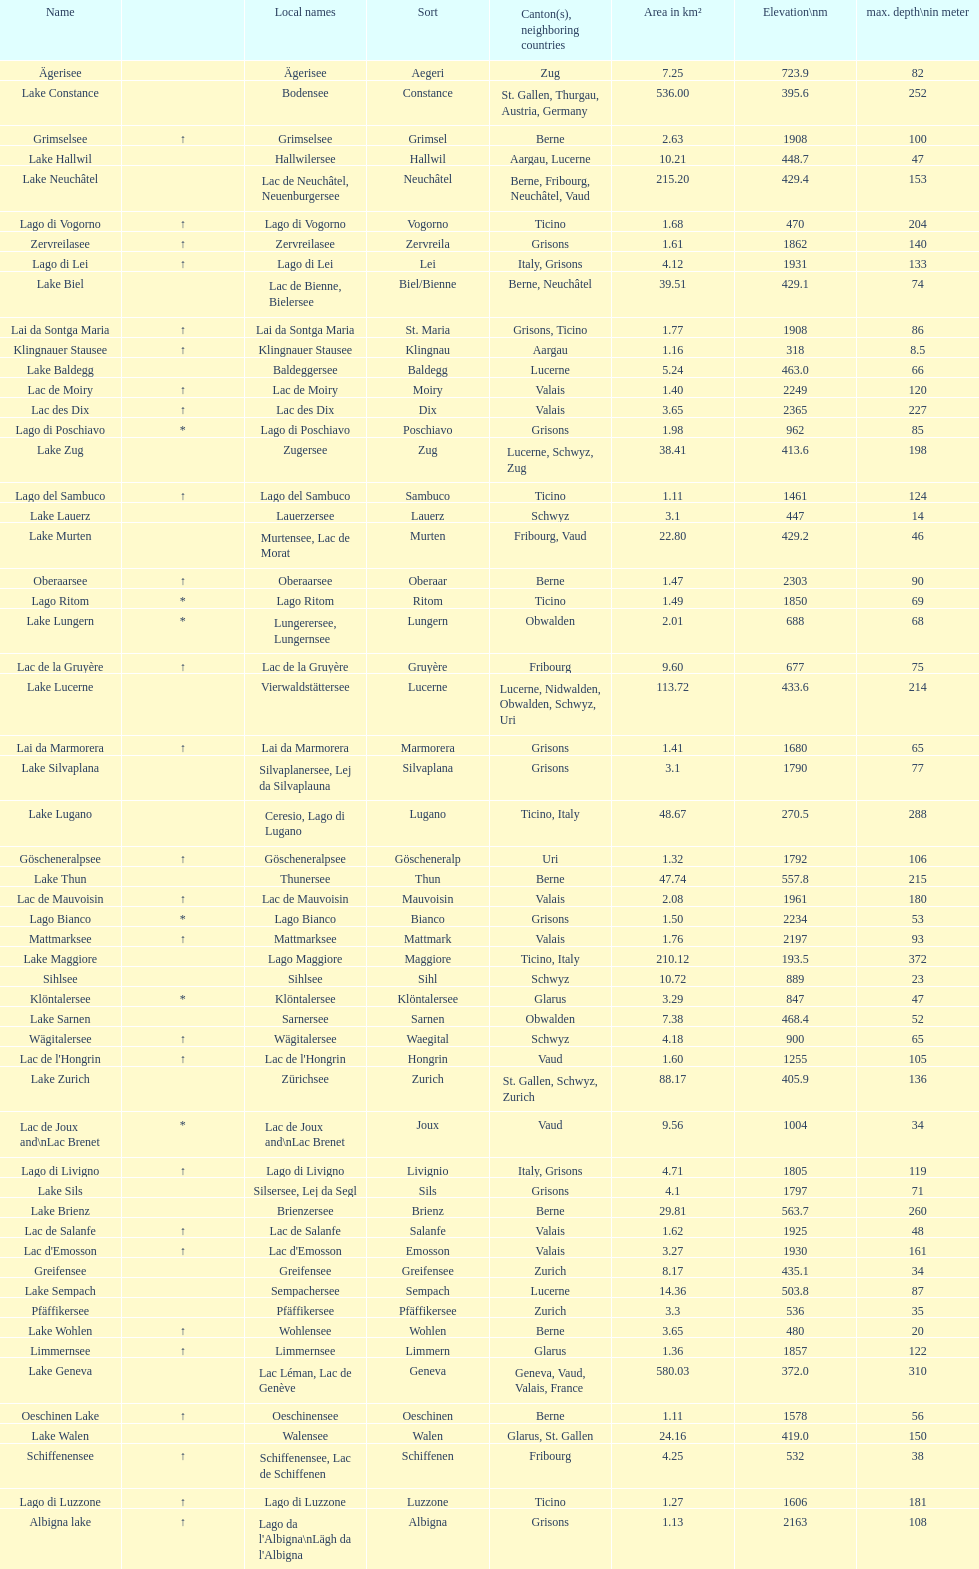What's the total max depth of lake geneva and lake constance combined? 562. Help me parse the entirety of this table. {'header': ['Name', '', 'Local names', 'Sort', 'Canton(s), neighboring countries', 'Area in km²', 'Elevation\\nm', 'max. depth\\nin meter'], 'rows': [['Ägerisee', '', 'Ägerisee', 'Aegeri', 'Zug', '7.25', '723.9', '82'], ['Lake Constance', '', 'Bodensee', 'Constance', 'St. Gallen, Thurgau, Austria, Germany', '536.00', '395.6', '252'], ['Grimselsee', '↑', 'Grimselsee', 'Grimsel', 'Berne', '2.63', '1908', '100'], ['Lake Hallwil', '', 'Hallwilersee', 'Hallwil', 'Aargau, Lucerne', '10.21', '448.7', '47'], ['Lake Neuchâtel', '', 'Lac de Neuchâtel, Neuenburgersee', 'Neuchâtel', 'Berne, Fribourg, Neuchâtel, Vaud', '215.20', '429.4', '153'], ['Lago di Vogorno', '↑', 'Lago di Vogorno', 'Vogorno', 'Ticino', '1.68', '470', '204'], ['Zervreilasee', '↑', 'Zervreilasee', 'Zervreila', 'Grisons', '1.61', '1862', '140'], ['Lago di Lei', '↑', 'Lago di Lei', 'Lei', 'Italy, Grisons', '4.12', '1931', '133'], ['Lake Biel', '', 'Lac de Bienne, Bielersee', 'Biel/Bienne', 'Berne, Neuchâtel', '39.51', '429.1', '74'], ['Lai da Sontga Maria', '↑', 'Lai da Sontga Maria', 'St. Maria', 'Grisons, Ticino', '1.77', '1908', '86'], ['Klingnauer Stausee', '↑', 'Klingnauer Stausee', 'Klingnau', 'Aargau', '1.16', '318', '8.5'], ['Lake Baldegg', '', 'Baldeggersee', 'Baldegg', 'Lucerne', '5.24', '463.0', '66'], ['Lac de Moiry', '↑', 'Lac de Moiry', 'Moiry', 'Valais', '1.40', '2249', '120'], ['Lac des Dix', '↑', 'Lac des Dix', 'Dix', 'Valais', '3.65', '2365', '227'], ['Lago di Poschiavo', '*', 'Lago di Poschiavo', 'Poschiavo', 'Grisons', '1.98', '962', '85'], ['Lake Zug', '', 'Zugersee', 'Zug', 'Lucerne, Schwyz, Zug', '38.41', '413.6', '198'], ['Lago del Sambuco', '↑', 'Lago del Sambuco', 'Sambuco', 'Ticino', '1.11', '1461', '124'], ['Lake Lauerz', '', 'Lauerzersee', 'Lauerz', 'Schwyz', '3.1', '447', '14'], ['Lake Murten', '', 'Murtensee, Lac de Morat', 'Murten', 'Fribourg, Vaud', '22.80', '429.2', '46'], ['Oberaarsee', '↑', 'Oberaarsee', 'Oberaar', 'Berne', '1.47', '2303', '90'], ['Lago Ritom', '*', 'Lago Ritom', 'Ritom', 'Ticino', '1.49', '1850', '69'], ['Lake Lungern', '*', 'Lungerersee, Lungernsee', 'Lungern', 'Obwalden', '2.01', '688', '68'], ['Lac de la Gruyère', '↑', 'Lac de la Gruyère', 'Gruyère', 'Fribourg', '9.60', '677', '75'], ['Lake Lucerne', '', 'Vierwaldstättersee', 'Lucerne', 'Lucerne, Nidwalden, Obwalden, Schwyz, Uri', '113.72', '433.6', '214'], ['Lai da Marmorera', '↑', 'Lai da Marmorera', 'Marmorera', 'Grisons', '1.41', '1680', '65'], ['Lake Silvaplana', '', 'Silvaplanersee, Lej da Silvaplauna', 'Silvaplana', 'Grisons', '3.1', '1790', '77'], ['Lake Lugano', '', 'Ceresio, Lago di Lugano', 'Lugano', 'Ticino, Italy', '48.67', '270.5', '288'], ['Göscheneralpsee', '↑', 'Göscheneralpsee', 'Göscheneralp', 'Uri', '1.32', '1792', '106'], ['Lake Thun', '', 'Thunersee', 'Thun', 'Berne', '47.74', '557.8', '215'], ['Lac de Mauvoisin', '↑', 'Lac de Mauvoisin', 'Mauvoisin', 'Valais', '2.08', '1961', '180'], ['Lago Bianco', '*', 'Lago Bianco', 'Bianco', 'Grisons', '1.50', '2234', '53'], ['Mattmarksee', '↑', 'Mattmarksee', 'Mattmark', 'Valais', '1.76', '2197', '93'], ['Lake Maggiore', '', 'Lago Maggiore', 'Maggiore', 'Ticino, Italy', '210.12', '193.5', '372'], ['Sihlsee', '', 'Sihlsee', 'Sihl', 'Schwyz', '10.72', '889', '23'], ['Klöntalersee', '*', 'Klöntalersee', 'Klöntalersee', 'Glarus', '3.29', '847', '47'], ['Lake Sarnen', '', 'Sarnersee', 'Sarnen', 'Obwalden', '7.38', '468.4', '52'], ['Wägitalersee', '↑', 'Wägitalersee', 'Waegital', 'Schwyz', '4.18', '900', '65'], ["Lac de l'Hongrin", '↑', "Lac de l'Hongrin", 'Hongrin', 'Vaud', '1.60', '1255', '105'], ['Lake Zurich', '', 'Zürichsee', 'Zurich', 'St. Gallen, Schwyz, Zurich', '88.17', '405.9', '136'], ['Lac de Joux and\\nLac Brenet', '*', 'Lac de Joux and\\nLac Brenet', 'Joux', 'Vaud', '9.56', '1004', '34'], ['Lago di Livigno', '↑', 'Lago di Livigno', 'Livignio', 'Italy, Grisons', '4.71', '1805', '119'], ['Lake Sils', '', 'Silsersee, Lej da Segl', 'Sils', 'Grisons', '4.1', '1797', '71'], ['Lake Brienz', '', 'Brienzersee', 'Brienz', 'Berne', '29.81', '563.7', '260'], ['Lac de Salanfe', '↑', 'Lac de Salanfe', 'Salanfe', 'Valais', '1.62', '1925', '48'], ["Lac d'Emosson", '↑', "Lac d'Emosson", 'Emosson', 'Valais', '3.27', '1930', '161'], ['Greifensee', '', 'Greifensee', 'Greifensee', 'Zurich', '8.17', '435.1', '34'], ['Lake Sempach', '', 'Sempachersee', 'Sempach', 'Lucerne', '14.36', '503.8', '87'], ['Pfäffikersee', '', 'Pfäffikersee', 'Pfäffikersee', 'Zurich', '3.3', '536', '35'], ['Lake Wohlen', '↑', 'Wohlensee', 'Wohlen', 'Berne', '3.65', '480', '20'], ['Limmernsee', '↑', 'Limmernsee', 'Limmern', 'Glarus', '1.36', '1857', '122'], ['Lake Geneva', '', 'Lac Léman, Lac de Genève', 'Geneva', 'Geneva, Vaud, Valais, France', '580.03', '372.0', '310'], ['Oeschinen Lake', '↑', 'Oeschinensee', 'Oeschinen', 'Berne', '1.11', '1578', '56'], ['Lake Walen', '', 'Walensee', 'Walen', 'Glarus, St. Gallen', '24.16', '419.0', '150'], ['Schiffenensee', '↑', 'Schiffenensee, Lac de Schiffenen', 'Schiffenen', 'Fribourg', '4.25', '532', '38'], ['Lago di Luzzone', '↑', 'Lago di Luzzone', 'Luzzone', 'Ticino', '1.27', '1606', '181'], ['Albigna lake', '↑', "Lago da l'Albigna\\nLägh da l'Albigna", 'Albigna', 'Grisons', '1.13', '2163', '108']]} 